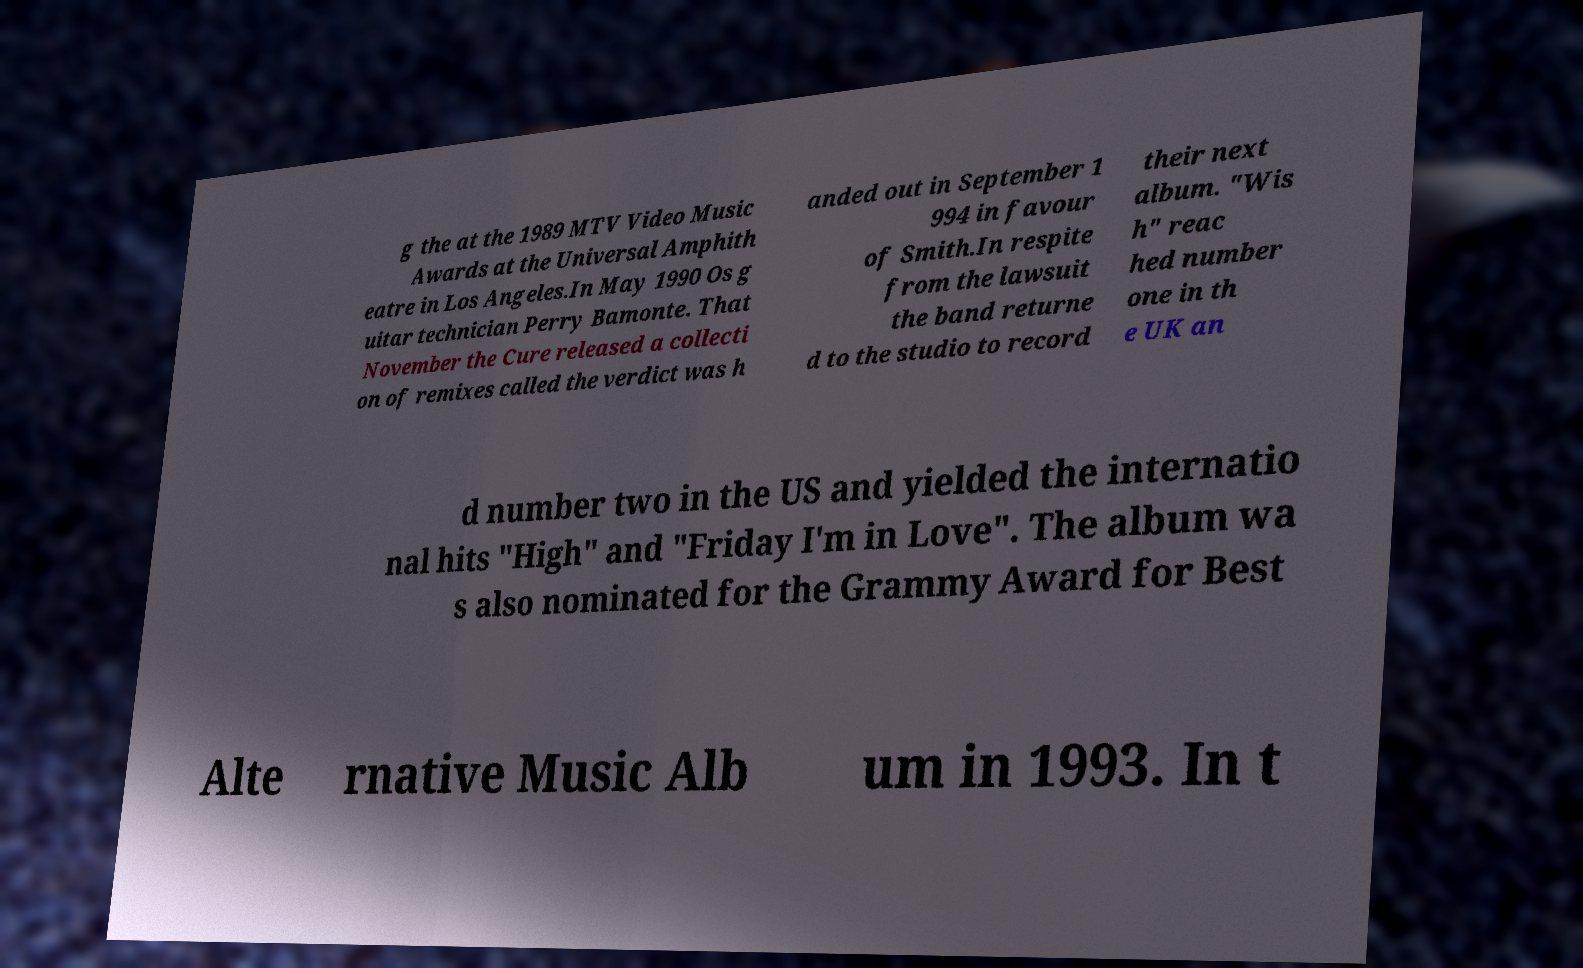What messages or text are displayed in this image? I need them in a readable, typed format. g the at the 1989 MTV Video Music Awards at the Universal Amphith eatre in Los Angeles.In May 1990 Os g uitar technician Perry Bamonte. That November the Cure released a collecti on of remixes called the verdict was h anded out in September 1 994 in favour of Smith.In respite from the lawsuit the band returne d to the studio to record their next album. "Wis h" reac hed number one in th e UK an d number two in the US and yielded the internatio nal hits "High" and "Friday I'm in Love". The album wa s also nominated for the Grammy Award for Best Alte rnative Music Alb um in 1993. In t 